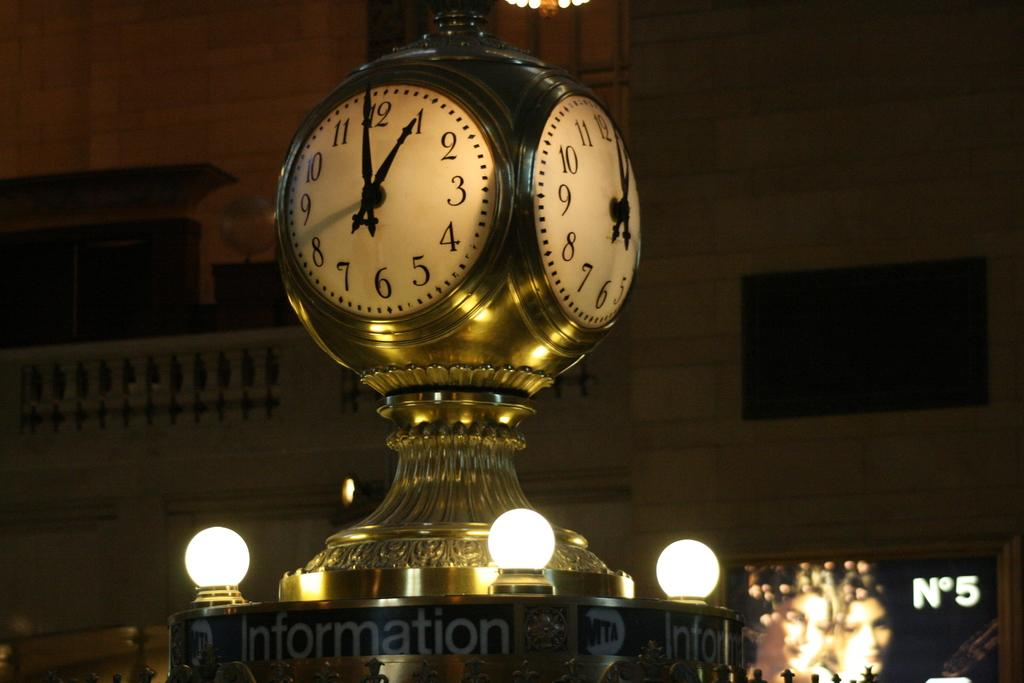<image>
Share a concise interpretation of the image provided. A round clock sits atop an information booth and shows that it is 1:00 currently. 